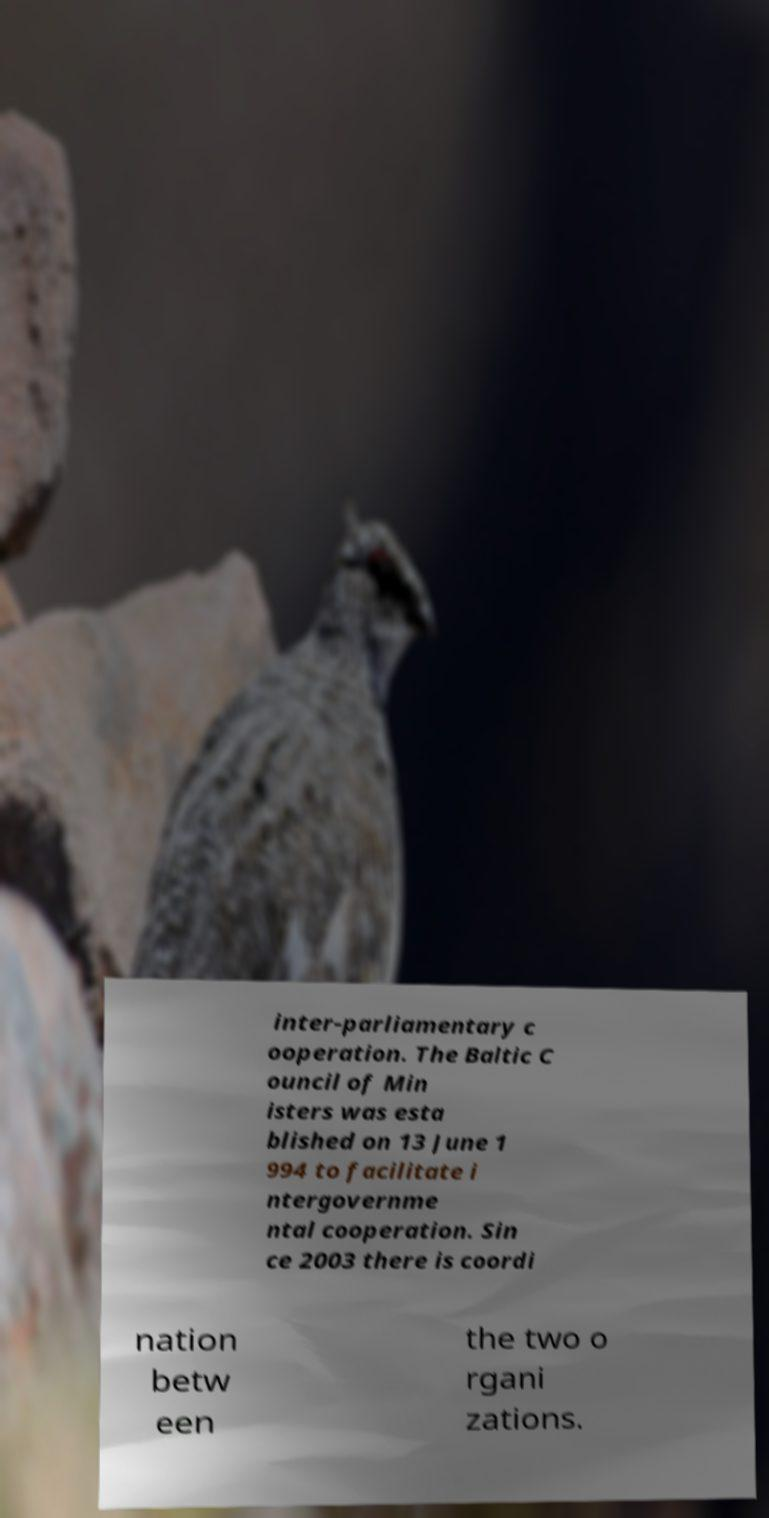Could you extract and type out the text from this image? inter-parliamentary c ooperation. The Baltic C ouncil of Min isters was esta blished on 13 June 1 994 to facilitate i ntergovernme ntal cooperation. Sin ce 2003 there is coordi nation betw een the two o rgani zations. 